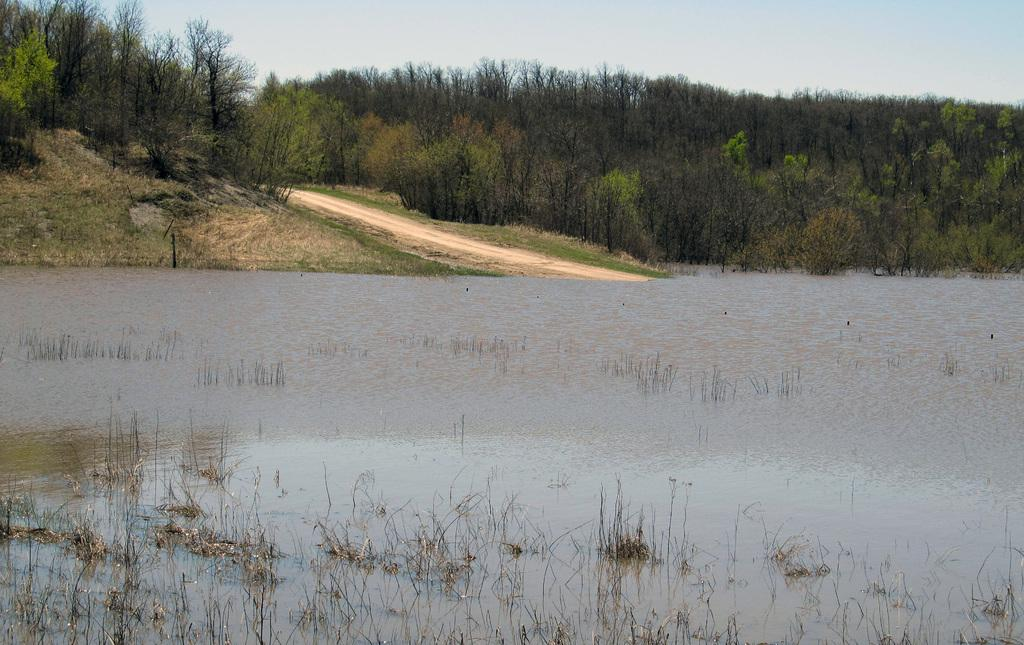What is located at the bottom of the image? There is a pond at the bottom of the image. What can be seen in the middle of the image? There are trees in the middle of the image. What is visible at the top of the image? The sky is visible at the top of the image. Can you tell me how many zebras are swimming in the pond in the image? There are no zebras present in the image; it features a pond, trees, and the sky. What type of lift is available for the trees in the image? There is no lift present in the image; it features a pond, trees, and the sky. 